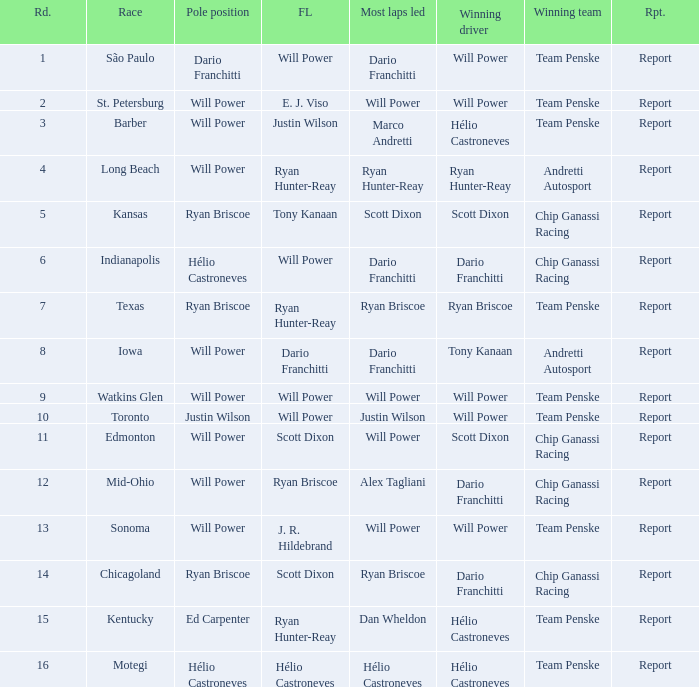In what position did the winning driver finish at Chicagoland? 1.0. 